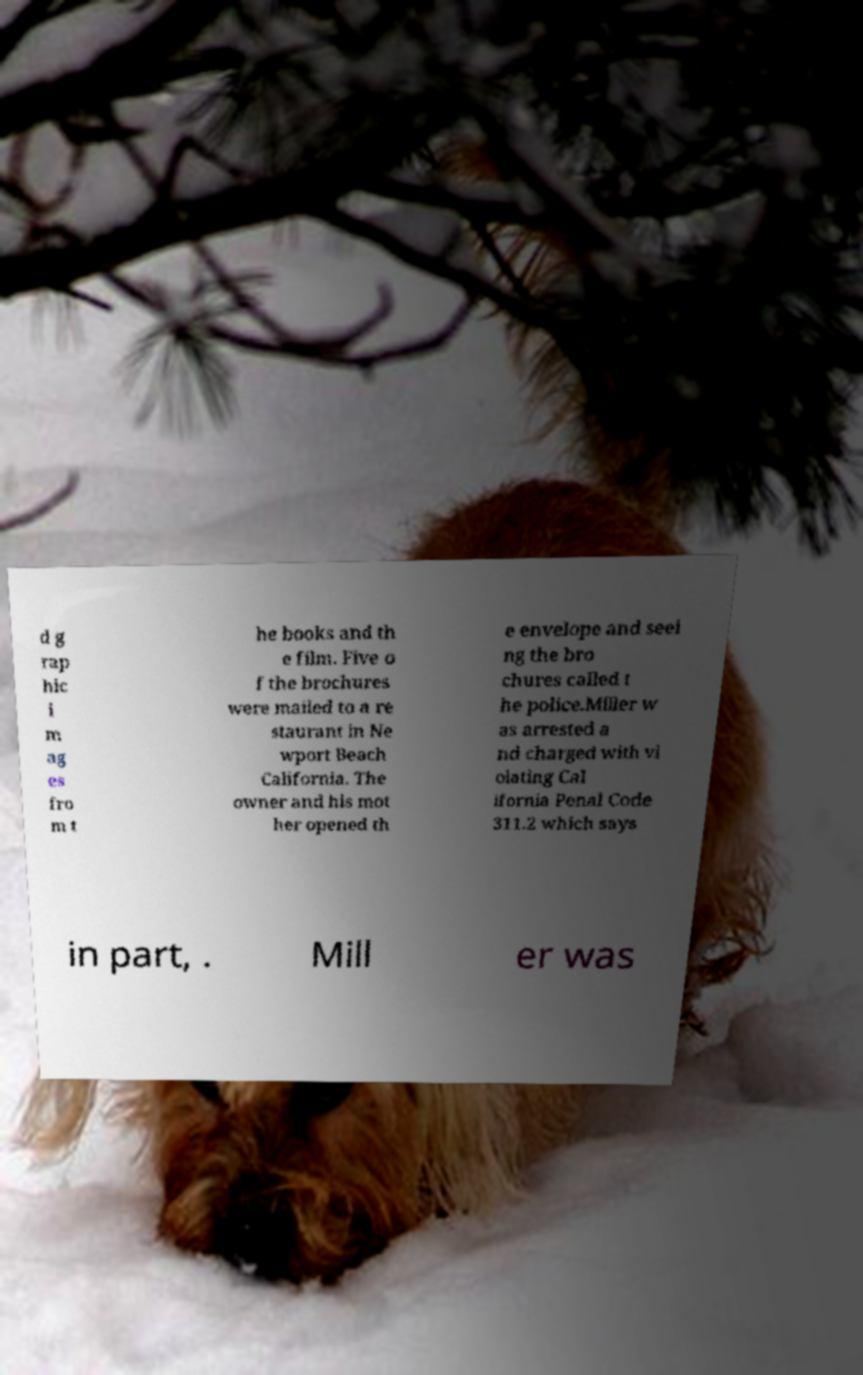Could you assist in decoding the text presented in this image and type it out clearly? d g rap hic i m ag es fro m t he books and th e film. Five o f the brochures were mailed to a re staurant in Ne wport Beach California. The owner and his mot her opened th e envelope and seei ng the bro chures called t he police.Miller w as arrested a nd charged with vi olating Cal ifornia Penal Code 311.2 which says in part, . Mill er was 